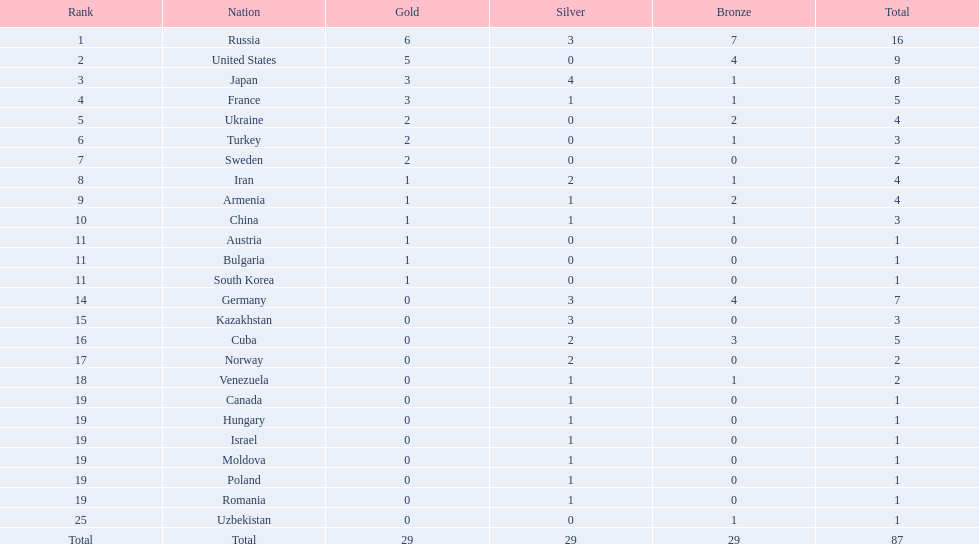Which states competed in the championships? Russia, United States, Japan, France, Ukraine, Turkey, Sweden, Iran, Armenia, China, Austria, Bulgaria, South Korea, Germany, Kazakhstan, Cuba, Norway, Venezuela, Canada, Hungary, Israel, Moldova, Poland, Romania, Uzbekistan. How many bronze medals were gained? 7, 4, 1, 1, 2, 1, 0, 1, 2, 1, 0, 0, 0, 4, 0, 3, 0, 1, 0, 0, 0, 0, 0, 0, 1, 29. What is the cumulative number? 16, 9, 8, 5, 4, 3, 2, 4, 4, 3, 1, 1, 1, 7, 3, 5, 2, 2, 1, 1, 1, 1, 1, 1, 1. And which team bagged only one medal - the bronze? Uzbekistan. 